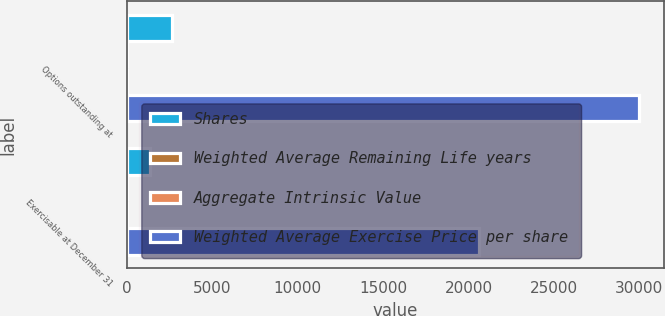<chart> <loc_0><loc_0><loc_500><loc_500><stacked_bar_chart><ecel><fcel>Options outstanding at<fcel>Exercisable at December 31<nl><fcel>Shares<fcel>2635<fcel>1378<nl><fcel>Weighted Average Remaining Life years<fcel>25.77<fcel>22.17<nl><fcel>Aggregate Intrinsic Value<fcel>4.2<fcel>3.2<nl><fcel>Weighted Average Exercise Price per share<fcel>29946<fcel>20610<nl></chart> 